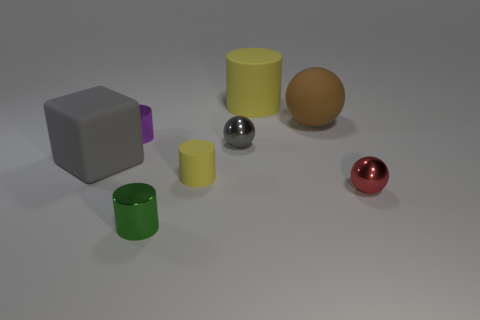How many objects are either green objects or big gray rubber blocks?
Provide a short and direct response. 2. There is a red thing that is made of the same material as the small green object; what is its shape?
Your response must be concise. Sphere. What number of tiny things are gray objects or green metallic objects?
Provide a succinct answer. 2. How many other objects are there of the same color as the matte cube?
Your answer should be very brief. 1. What number of gray balls are left of the small shiny sphere that is in front of the yellow cylinder that is in front of the matte block?
Your answer should be compact. 1. There is a thing in front of the red thing; is its size the same as the large gray object?
Your answer should be compact. No. Are there fewer gray matte cubes in front of the tiny matte object than yellow objects to the left of the red metal thing?
Offer a very short reply. Yes. Is the color of the big cylinder the same as the tiny matte object?
Ensure brevity in your answer.  Yes. Is the number of large things right of the large gray matte object less than the number of big metal things?
Give a very brief answer. No. There is a tiny thing that is the same color as the big rubber block; what is it made of?
Keep it short and to the point. Metal. 